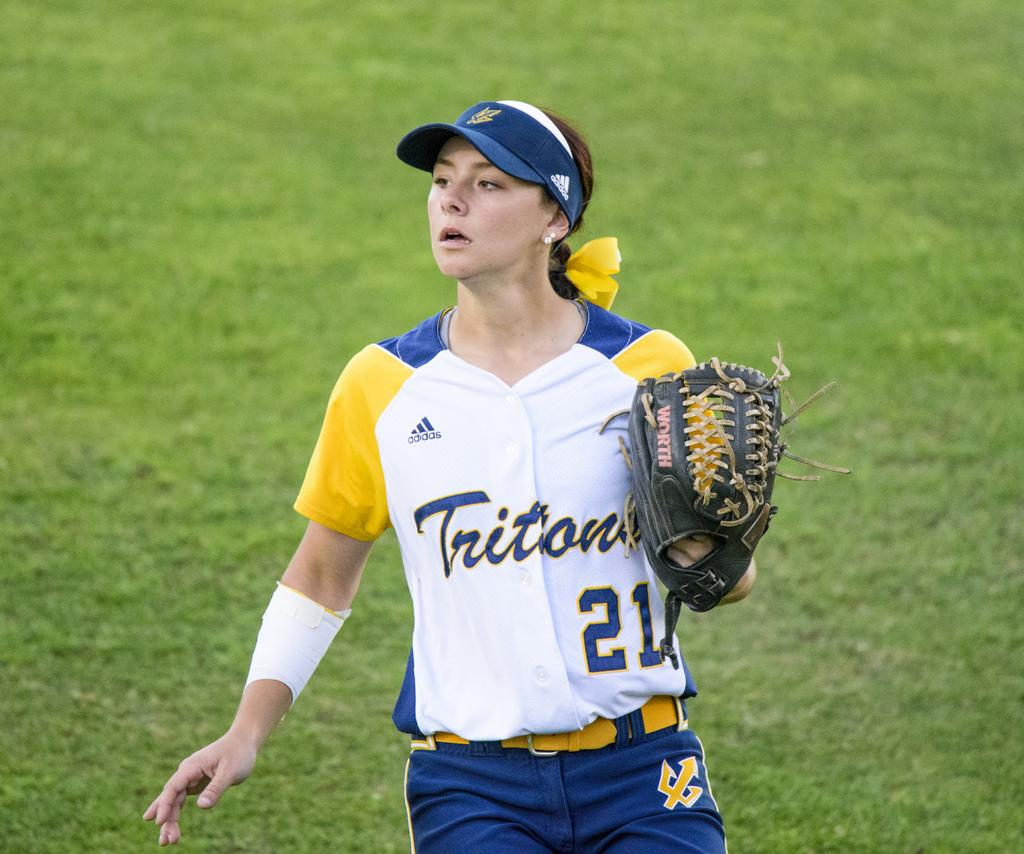<image>
Write a terse but informative summary of the picture. A player for the Tritons watches her teammate make the play. 